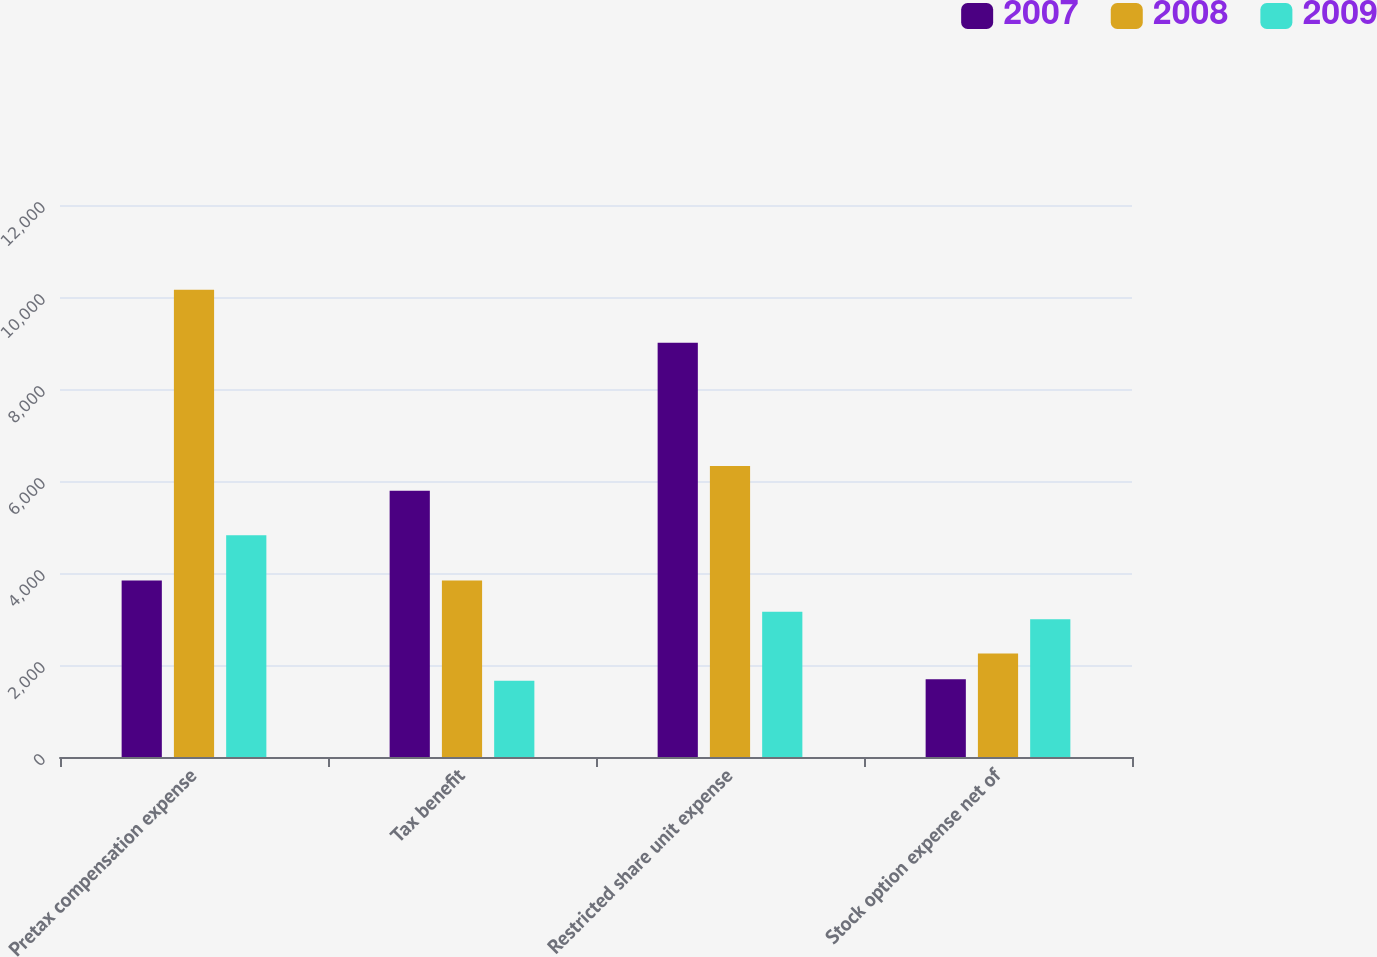<chart> <loc_0><loc_0><loc_500><loc_500><stacked_bar_chart><ecel><fcel>Pretax compensation expense<fcel>Tax benefit<fcel>Restricted share unit expense<fcel>Stock option expense net of<nl><fcel>2007<fcel>3835<fcel>5786<fcel>9008<fcel>1688<nl><fcel>2008<fcel>10160<fcel>3835<fcel>6325<fcel>2249<nl><fcel>2009<fcel>4820<fcel>1660<fcel>3160<fcel>2996<nl></chart> 